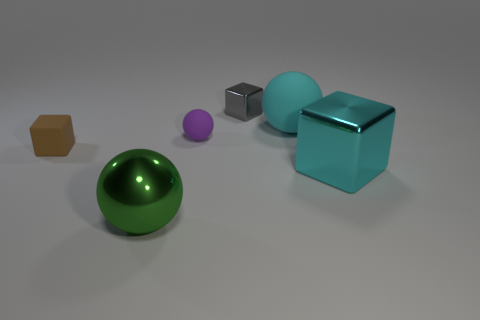Subtract all metal balls. How many balls are left? 2 Add 3 yellow metal cylinders. How many objects exist? 9 Subtract all cyan blocks. Subtract all tiny rubber objects. How many objects are left? 3 Add 1 cyan cubes. How many cyan cubes are left? 2 Add 1 large yellow matte cylinders. How many large yellow matte cylinders exist? 1 Subtract all gray cubes. How many cubes are left? 2 Subtract 1 purple spheres. How many objects are left? 5 Subtract all yellow spheres. Subtract all cyan cylinders. How many spheres are left? 3 Subtract all gray blocks. How many cyan spheres are left? 1 